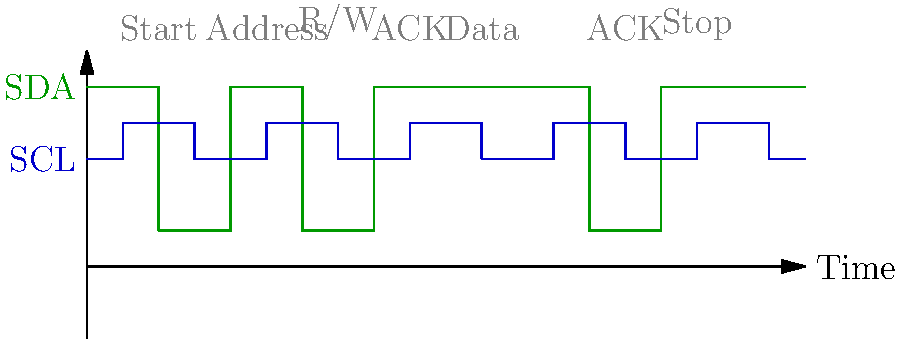In the given I2C timing diagram, how many clock cycles are required for the complete transaction, including the start and stop conditions? To determine the number of clock cycles in this I2C transaction, let's break it down step-by-step:

1. Start condition: This is signaled by SDA going low while SCL is high. It doesn't count as a clock cycle.

2. Address transmission: I2C addresses are typically 7 bits long. We can see 7 clock pulses after the start condition.

3. Read/Write bit: This is the 8th bit transmitted, determining whether the master will read from or write to the slave.

4. ACK bit: After the 8 bits (7-bit address + R/W bit), there's one clock cycle for the slave to acknowledge.

5. Data transmission: We can see 8 more clock pulses, representing an 8-bit data byte.

6. ACK bit: There's another clock cycle for acknowledging the data byte.

7. Stop condition: This is signaled by SDA going high while SCL is high. Like the start condition, it doesn't count as a clock cycle.

Counting the clock pulses:
- 7 for address
- 1 for R/W bit
- 1 for first ACK
- 8 for data
- 1 for second ACK

Total: 7 + 1 + 1 + 8 + 1 = 18 clock cycles
Answer: 18 clock cycles 